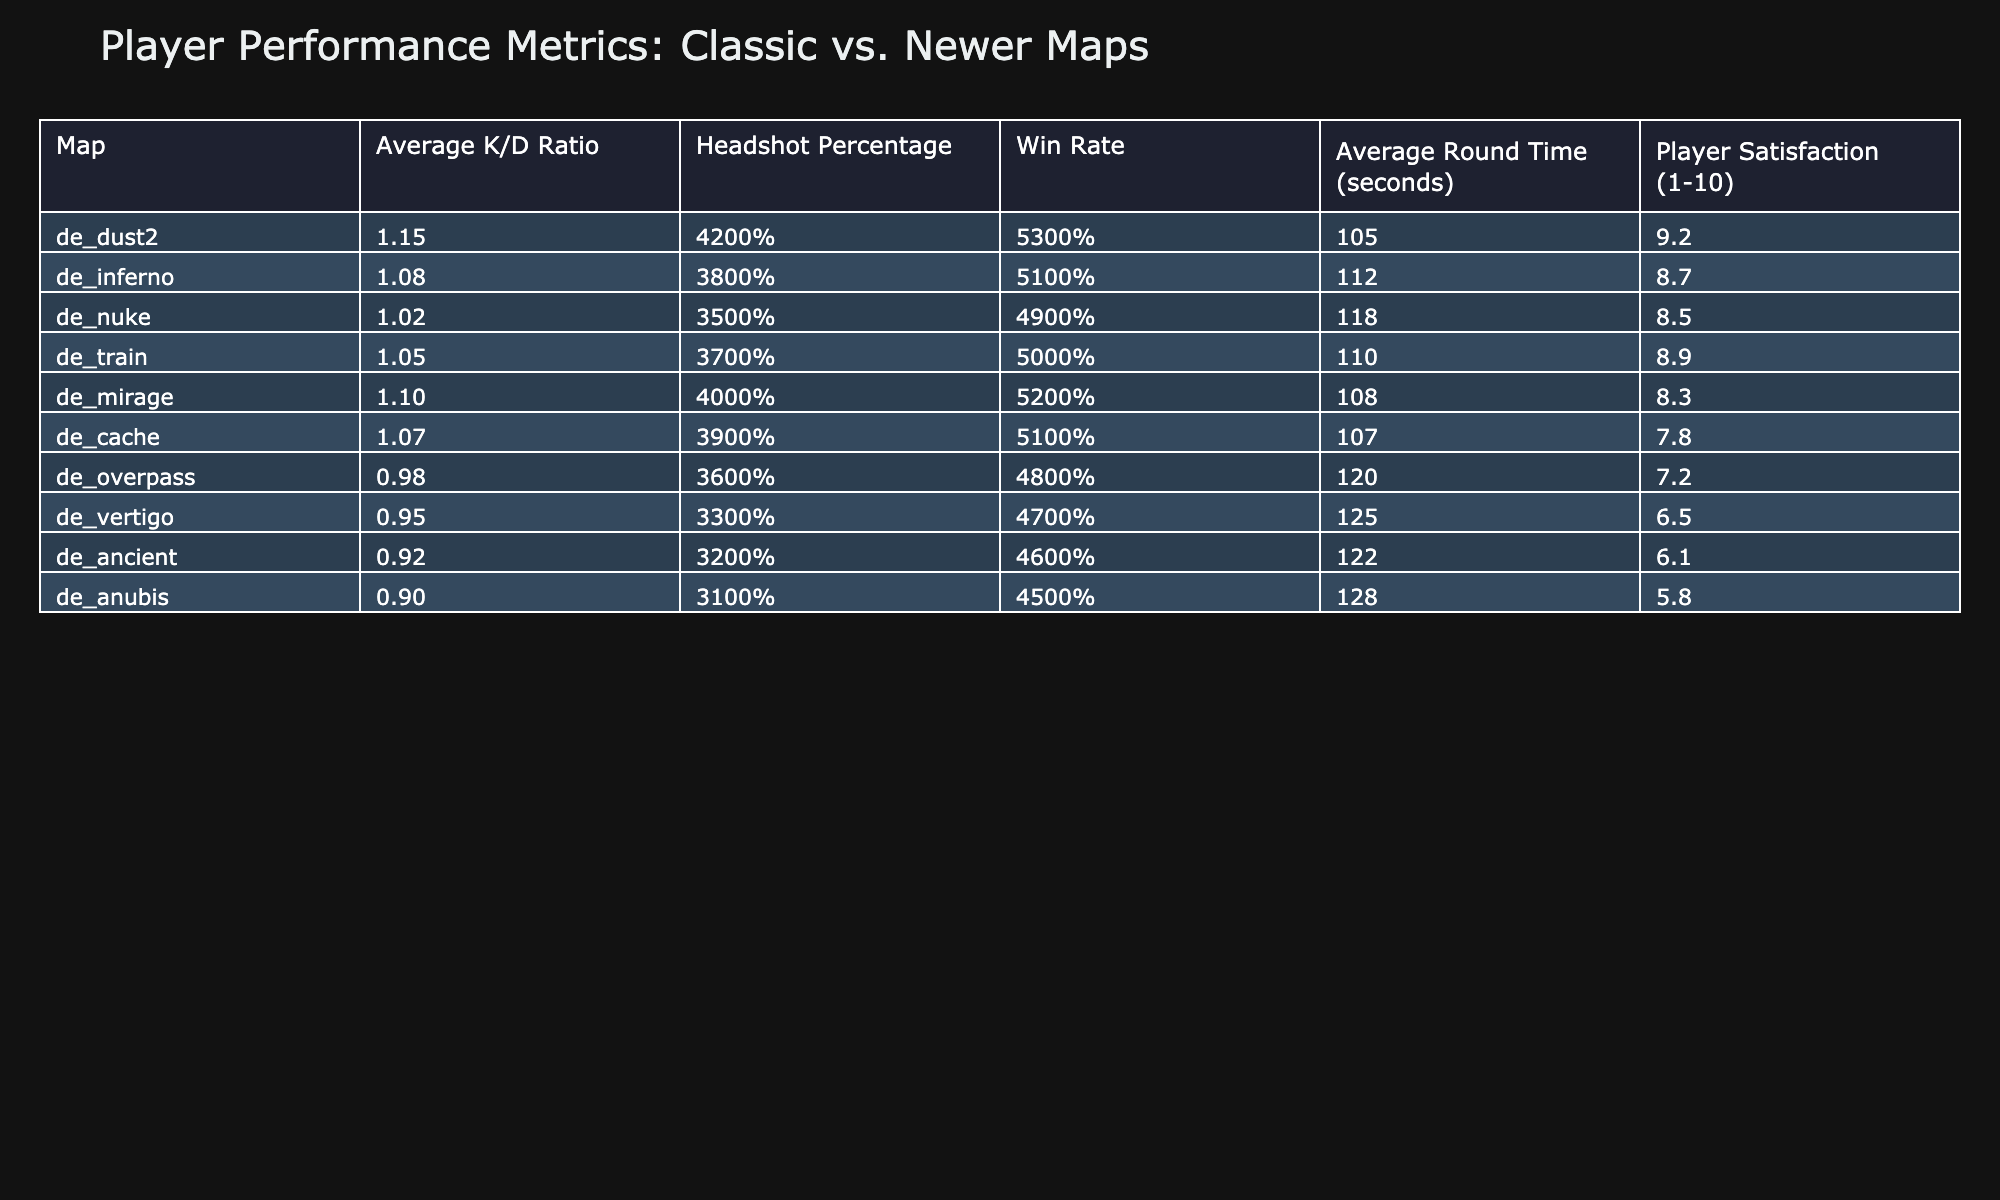What is the average K/D ratio for the classic maps? The classic maps presented are de_dust2, de_inferno, de_nuke, de_train, and de_mirage. Their K/D ratios are 1.15, 1.08, 1.02, 1.05, and 1.10. We can calculate the average by summing these values (1.15 + 1.08 + 1.02 + 1.05 + 1.10 = 5.40) and dividing by the number of maps (5). This results in an average of 5.40 / 5 = 1.08.
Answer: 1.08 Which map has the highest headshot percentage? All the maps are listed with their headshot percentages. Looking at the data, de_dust2 has the highest value at 42%, while the others are lower.
Answer: de_dust2 Is the win rate for de_overpass greater than 50%? The win rate for de_overpass is listed as 48%. Since 48% is less than 50%, the answer is no.
Answer: No What is the difference in player satisfaction between the highest and lowest-rated maps? The highest-rated map is de_dust2 with a player satisfaction of 9.2, and the lowest-rated is de_anubis with a satisfaction of 5.8. To find the difference, we subtract the lowest from the highest (9.2 - 5.8 = 3.4).
Answer: 3.4 Which newer map has the lowest K/D ratio? The newer maps are de_overpass, de_vertigo, de_ancient, and de_anubis. Their K/D ratios are 0.98, 0.95, 0.92, and 0.90, respectively. Comparing these, de_anubis has the lowest K/D ratio at 0.90.
Answer: de_anubis What is the average round time for all maps? The round times for all maps need to be added up: 105 + 112 + 118 + 110 + 108 + 107 + 120 + 125 + 122 + 128 = 1,158 seconds. There are 10 maps, so the average is calculated as 1,158 seconds / 10 = 115.8 seconds.
Answer: 115.8 seconds Does de_train have a headshot percentage less than 40%? The headshot percentage for de_train is reported as 37%. Since this is less than 40%, the answer is yes.
Answer: Yes Which map has a win rate greater than 50% and the highest player satisfaction? The maps having win rates greater than 50% are de_dust2 (53%) and de_mirage (52%). Of these, de_dust2 has the highest player satisfaction score of 9.2. Thus, the answer is de_dust2.
Answer: de_dust2 What is the combined K/D ratio of the two highest-rated classic maps? The two highest-rated classic maps are de_dust2 (1.15) and de_inferno (1.08). Their combined K/D ratio is calculated by adding these two values: 1.15 + 1.08 = 2.23.
Answer: 2.23 